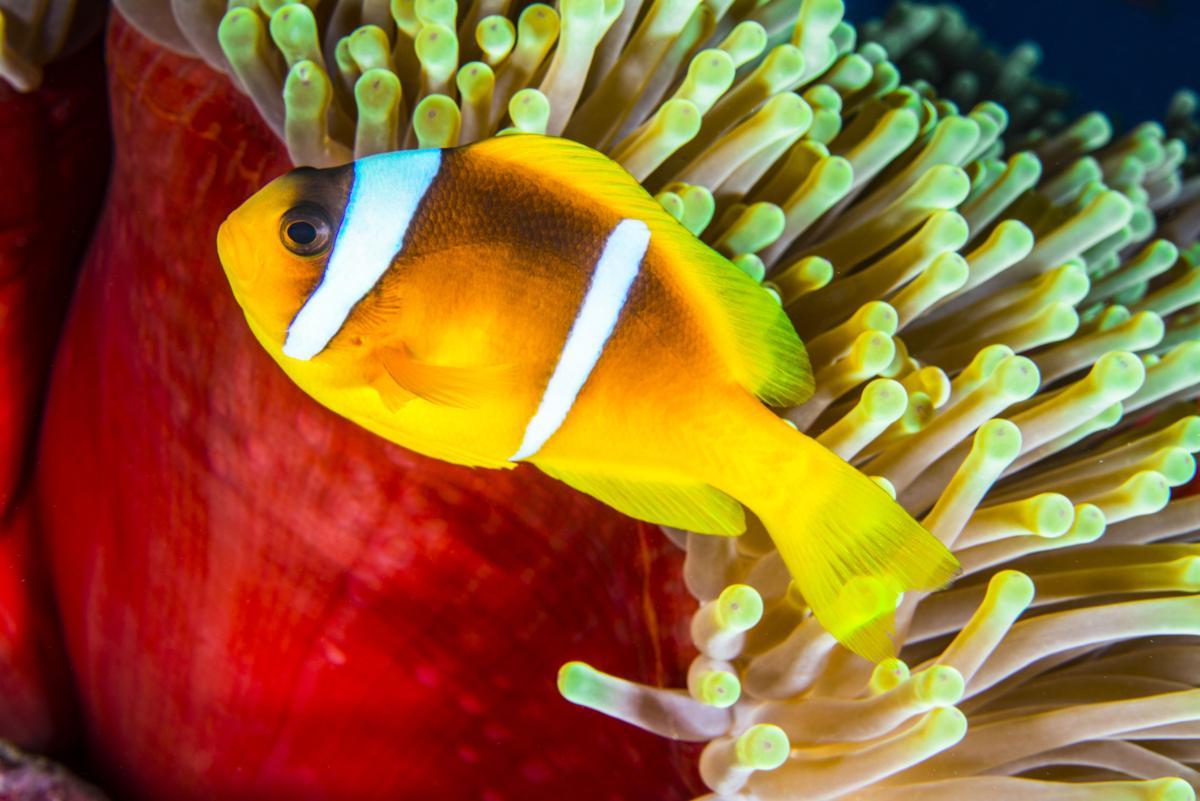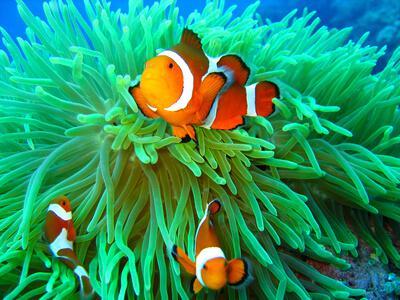The first image is the image on the left, the second image is the image on the right. Examine the images to the left and right. Is the description "There is exactly one fish in the image on the right." accurate? Answer yes or no. No. The first image is the image on the left, the second image is the image on the right. Considering the images on both sides, is "The right image shows more than one clown fish swimming among tube shapes." valid? Answer yes or no. Yes. 